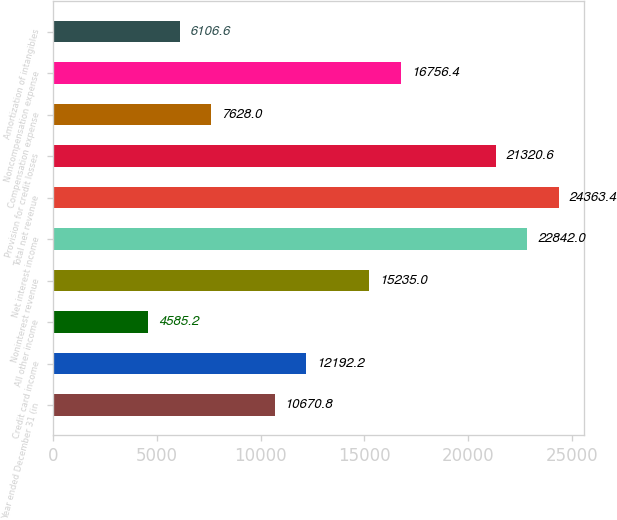Convert chart. <chart><loc_0><loc_0><loc_500><loc_500><bar_chart><fcel>Year ended December 31 (in<fcel>Credit card income<fcel>All other income<fcel>Noninterest revenue<fcel>Net interest income<fcel>Total net revenue<fcel>Provision for credit losses<fcel>Compensation expense<fcel>Noncompensation expense<fcel>Amortization of intangibles<nl><fcel>10670.8<fcel>12192.2<fcel>4585.2<fcel>15235<fcel>22842<fcel>24363.4<fcel>21320.6<fcel>7628<fcel>16756.4<fcel>6106.6<nl></chart> 